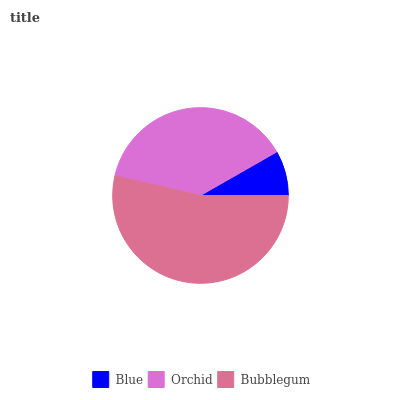Is Blue the minimum?
Answer yes or no. Yes. Is Bubblegum the maximum?
Answer yes or no. Yes. Is Orchid the minimum?
Answer yes or no. No. Is Orchid the maximum?
Answer yes or no. No. Is Orchid greater than Blue?
Answer yes or no. Yes. Is Blue less than Orchid?
Answer yes or no. Yes. Is Blue greater than Orchid?
Answer yes or no. No. Is Orchid less than Blue?
Answer yes or no. No. Is Orchid the high median?
Answer yes or no. Yes. Is Orchid the low median?
Answer yes or no. Yes. Is Bubblegum the high median?
Answer yes or no. No. Is Bubblegum the low median?
Answer yes or no. No. 